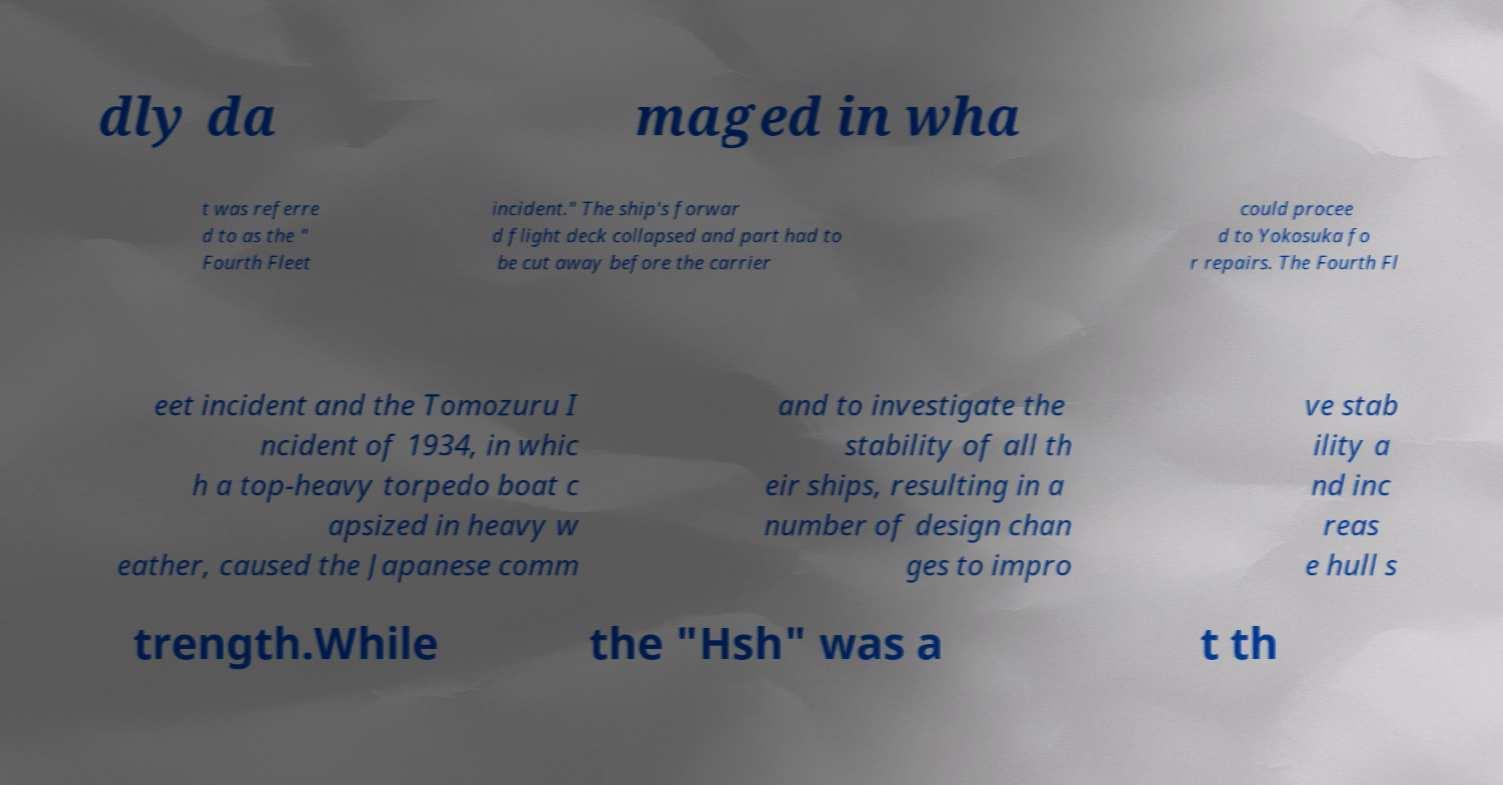Can you read and provide the text displayed in the image?This photo seems to have some interesting text. Can you extract and type it out for me? dly da maged in wha t was referre d to as the " Fourth Fleet incident." The ship's forwar d flight deck collapsed and part had to be cut away before the carrier could procee d to Yokosuka fo r repairs. The Fourth Fl eet incident and the Tomozuru I ncident of 1934, in whic h a top-heavy torpedo boat c apsized in heavy w eather, caused the Japanese comm and to investigate the stability of all th eir ships, resulting in a number of design chan ges to impro ve stab ility a nd inc reas e hull s trength.While the "Hsh" was a t th 